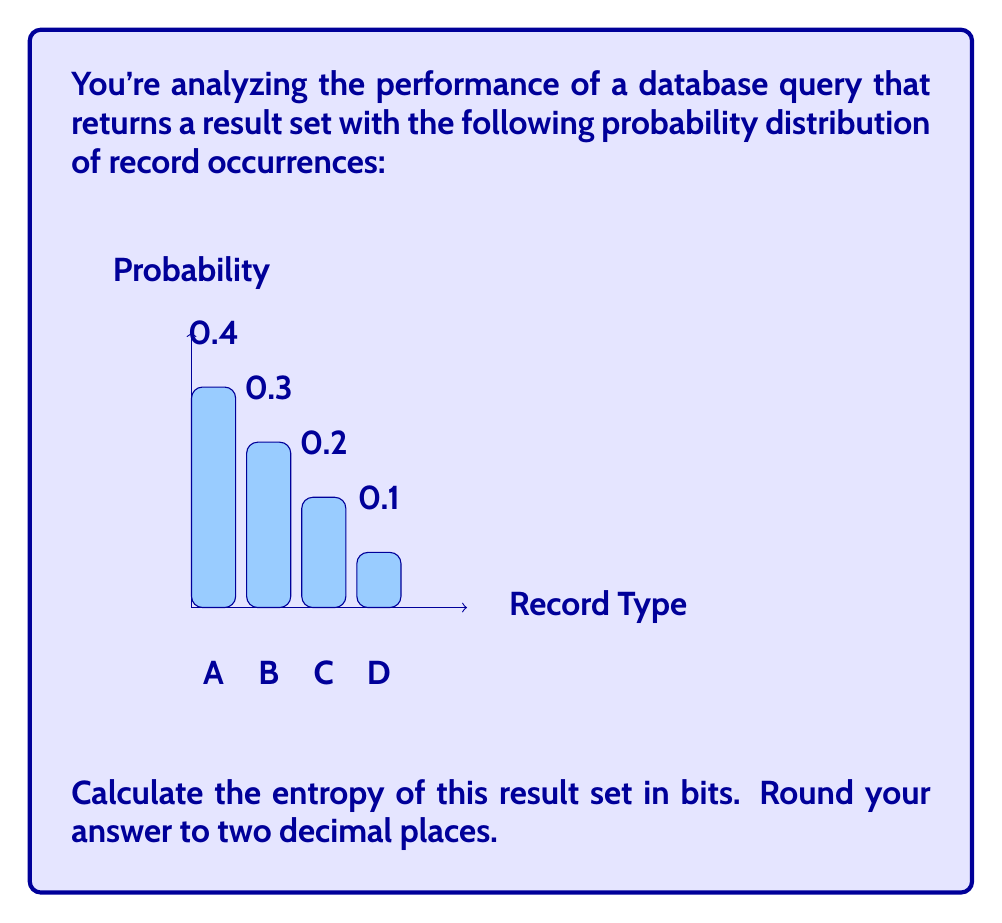Help me with this question. To calculate the entropy of the database query result set, we'll use the formula for Shannon entropy:

$$H = -\sum_{i=1}^{n} p_i \log_2(p_i)$$

Where $p_i$ is the probability of each outcome, and $n$ is the number of possible outcomes.

Step 1: Identify the probabilities
$p_A = 0.4$
$p_B = 0.3$
$p_C = 0.2$
$p_D = 0.1$

Step 2: Calculate each term of the sum
For A: $-0.4 \log_2(0.4) = 0.528321$
For B: $-0.3 \log_2(0.3) = 0.521436$
For C: $-0.2 \log_2(0.2) = 0.464386$
For D: $-0.1 \log_2(0.1) = 0.332193$

Step 3: Sum all terms
$H = 0.528321 + 0.521436 + 0.464386 + 0.332193 = 1.846336$ bits

Step 4: Round to two decimal places
$H \approx 1.85$ bits
Answer: 1.85 bits 